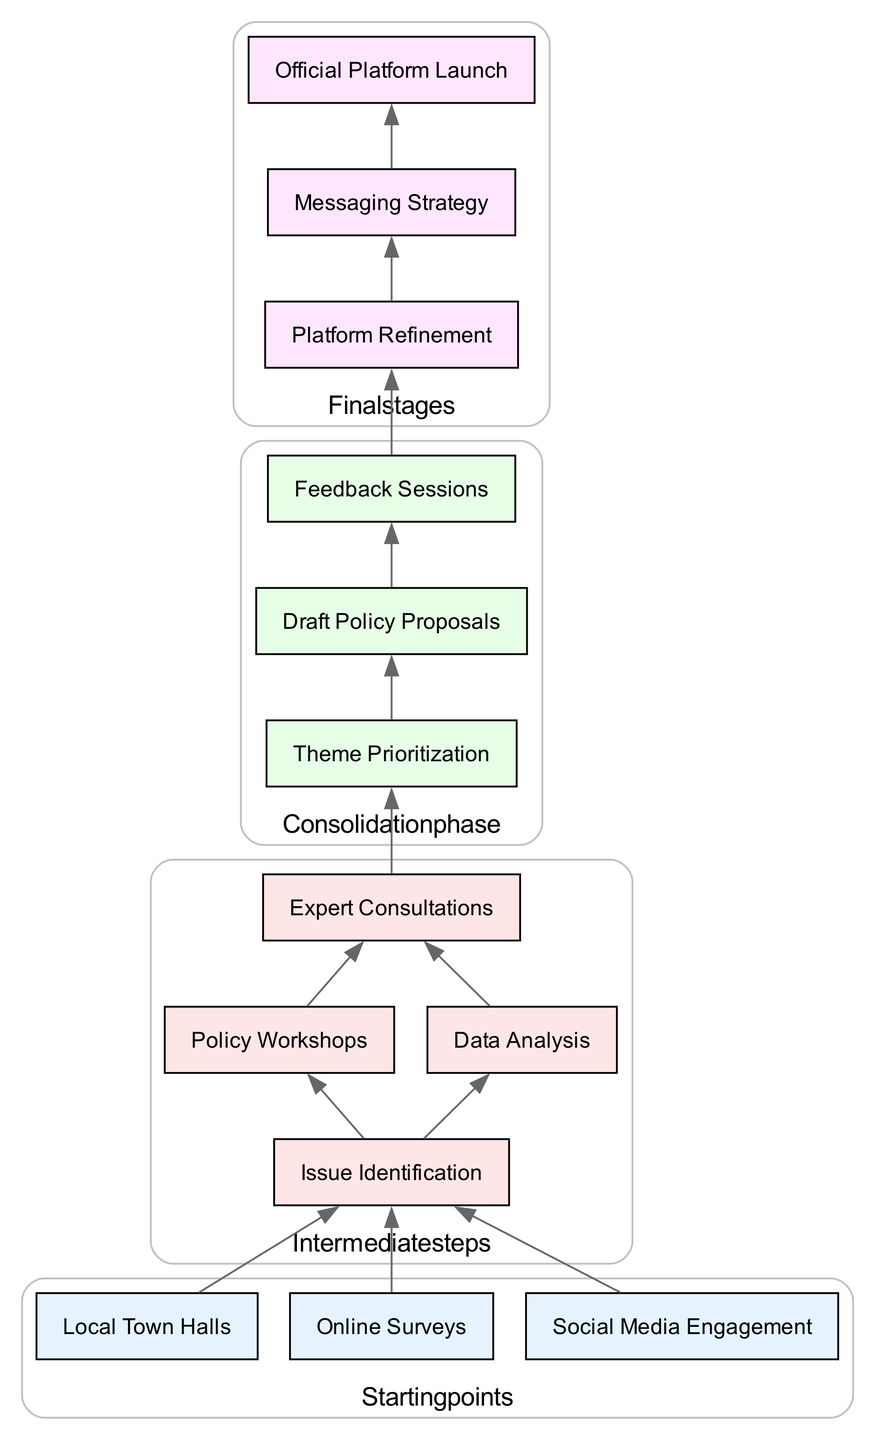What are the starting points for building a political party's platform? The starting points are the initial nodes in the diagram. They are: Local Town Halls, Online Surveys, and Social Media Engagement. Each of these points leads to the issue identification stage.
Answer: Local Town Halls, Online Surveys, Social Media Engagement How many intermediate steps are there in the diagram? The intermediate steps are listed as individual nodes. By counting them, we find there are four intermediate steps: Issue Identification, Policy Workshops, Data Analysis, and Expert Consultations.
Answer: 4 Which node connects directly to Theme Prioritization? To determine this, we look for the node that points directly to Theme Prioritization in the diagram. The preceding node is Expert Consultations, which leads directly to Theme Prioritization.
Answer: Expert Consultations What is the last stage of the platform building process? The last stage is located at the bottom of the flowchart. The final stages cascade to Official Platform Launch, which is the last node in the diagram.
Answer: Official Platform Launch Which nodes precede the Draft Policy Proposals stage? To find this, we identify the nodes that connect to Draft Policy Proposals in the flowchart. The direct preceding node is Theme Prioritization, which feeds into Draft Policy Proposals.
Answer: Theme Prioritization What is the total number of connections between nodes? Each connection in the diagram represents a directed edge between two nodes. By counting all the lines connecting the different stages, we find there are 12 connections in total.
Answer: 12 What two stages come after Feedback Sessions? We look for the nodes that are directly downstream of the Feedback Sessions. The following stages after Feedback Sessions are Platform Refinement and Messaging Strategy.
Answer: Platform Refinement, Messaging Strategy How does the process of issue identification begin? The process begins by connecting to three different starting points: Local Town Halls, Online Surveys, and Social Media Engagement. These all flow into the Issue Identification node.
Answer: Local Town Halls, Online Surveys, Social Media Engagement What stage originates from the Data Analysis step? To identify this, we can track the arrows leading from Data Analysis in the diagram. The direct next step is Expert Consultations, which is connected to Data Analysis.
Answer: Expert Consultations 